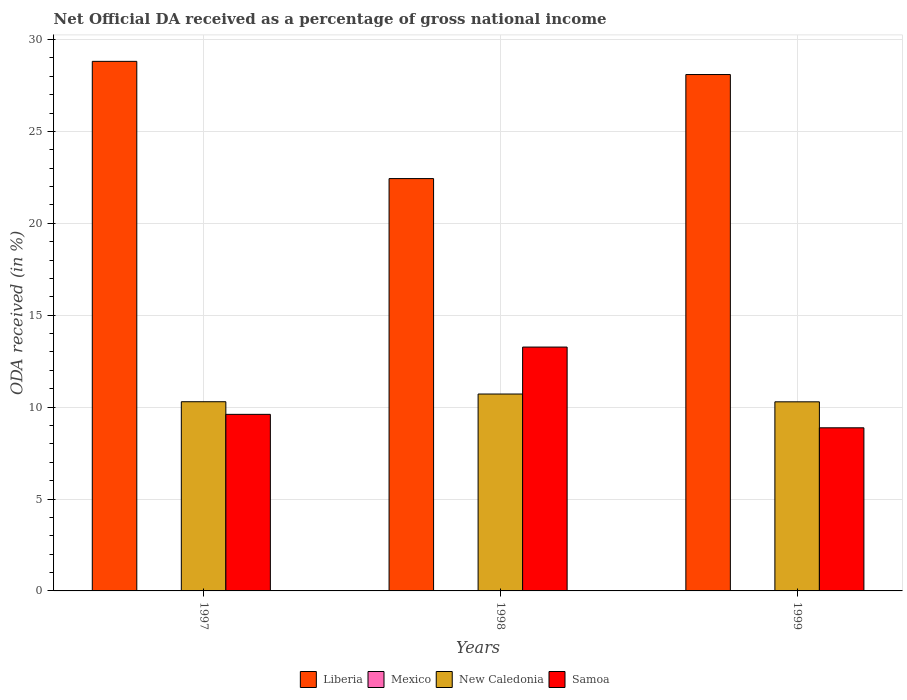How many different coloured bars are there?
Offer a very short reply. 4. Are the number of bars per tick equal to the number of legend labels?
Your answer should be very brief. Yes. How many bars are there on the 3rd tick from the left?
Ensure brevity in your answer.  4. How many bars are there on the 2nd tick from the right?
Offer a very short reply. 4. In how many cases, is the number of bars for a given year not equal to the number of legend labels?
Your response must be concise. 0. What is the net official DA received in Liberia in 1998?
Offer a terse response. 22.43. Across all years, what is the maximum net official DA received in New Caledonia?
Provide a short and direct response. 10.71. Across all years, what is the minimum net official DA received in Mexico?
Offer a terse response. 0. In which year was the net official DA received in Mexico minimum?
Give a very brief answer. 1998. What is the total net official DA received in Mexico in the graph?
Ensure brevity in your answer.  0.03. What is the difference between the net official DA received in New Caledonia in 1997 and that in 1999?
Your answer should be compact. 0.01. What is the difference between the net official DA received in New Caledonia in 1998 and the net official DA received in Liberia in 1999?
Your answer should be very brief. -17.38. What is the average net official DA received in Samoa per year?
Ensure brevity in your answer.  10.58. In the year 1998, what is the difference between the net official DA received in New Caledonia and net official DA received in Samoa?
Your answer should be compact. -2.55. In how many years, is the net official DA received in Mexico greater than 23 %?
Make the answer very short. 0. What is the ratio of the net official DA received in Samoa in 1997 to that in 1998?
Offer a very short reply. 0.72. What is the difference between the highest and the second highest net official DA received in New Caledonia?
Your answer should be compact. 0.42. What is the difference between the highest and the lowest net official DA received in New Caledonia?
Provide a succinct answer. 0.42. In how many years, is the net official DA received in Liberia greater than the average net official DA received in Liberia taken over all years?
Ensure brevity in your answer.  2. Is the sum of the net official DA received in Mexico in 1997 and 1999 greater than the maximum net official DA received in Samoa across all years?
Give a very brief answer. No. What does the 4th bar from the left in 1999 represents?
Offer a very short reply. Samoa. What does the 4th bar from the right in 1997 represents?
Keep it short and to the point. Liberia. Is it the case that in every year, the sum of the net official DA received in Mexico and net official DA received in New Caledonia is greater than the net official DA received in Samoa?
Offer a very short reply. No. How many bars are there?
Your answer should be compact. 12. Are all the bars in the graph horizontal?
Ensure brevity in your answer.  No. How many years are there in the graph?
Your response must be concise. 3. Are the values on the major ticks of Y-axis written in scientific E-notation?
Offer a terse response. No. Where does the legend appear in the graph?
Provide a succinct answer. Bottom center. How are the legend labels stacked?
Offer a terse response. Horizontal. What is the title of the graph?
Your response must be concise. Net Official DA received as a percentage of gross national income. Does "Kosovo" appear as one of the legend labels in the graph?
Provide a succinct answer. No. What is the label or title of the X-axis?
Give a very brief answer. Years. What is the label or title of the Y-axis?
Provide a succinct answer. ODA received (in %). What is the ODA received (in %) of Liberia in 1997?
Offer a terse response. 28.81. What is the ODA received (in %) in Mexico in 1997?
Ensure brevity in your answer.  0.02. What is the ODA received (in %) of New Caledonia in 1997?
Ensure brevity in your answer.  10.29. What is the ODA received (in %) in Samoa in 1997?
Ensure brevity in your answer.  9.61. What is the ODA received (in %) of Liberia in 1998?
Your answer should be compact. 22.43. What is the ODA received (in %) in Mexico in 1998?
Ensure brevity in your answer.  0. What is the ODA received (in %) of New Caledonia in 1998?
Keep it short and to the point. 10.71. What is the ODA received (in %) of Samoa in 1998?
Offer a terse response. 13.27. What is the ODA received (in %) of Liberia in 1999?
Your answer should be very brief. 28.1. What is the ODA received (in %) in Mexico in 1999?
Provide a succinct answer. 0.01. What is the ODA received (in %) of New Caledonia in 1999?
Your answer should be very brief. 10.29. What is the ODA received (in %) of Samoa in 1999?
Your answer should be very brief. 8.87. Across all years, what is the maximum ODA received (in %) of Liberia?
Keep it short and to the point. 28.81. Across all years, what is the maximum ODA received (in %) of Mexico?
Your answer should be very brief. 0.02. Across all years, what is the maximum ODA received (in %) in New Caledonia?
Your answer should be very brief. 10.71. Across all years, what is the maximum ODA received (in %) in Samoa?
Provide a succinct answer. 13.27. Across all years, what is the minimum ODA received (in %) of Liberia?
Offer a very short reply. 22.43. Across all years, what is the minimum ODA received (in %) of Mexico?
Provide a succinct answer. 0. Across all years, what is the minimum ODA received (in %) in New Caledonia?
Provide a short and direct response. 10.29. Across all years, what is the minimum ODA received (in %) of Samoa?
Your answer should be compact. 8.87. What is the total ODA received (in %) in Liberia in the graph?
Make the answer very short. 79.34. What is the total ODA received (in %) of Mexico in the graph?
Make the answer very short. 0.03. What is the total ODA received (in %) of New Caledonia in the graph?
Offer a terse response. 31.29. What is the total ODA received (in %) of Samoa in the graph?
Your answer should be very brief. 31.75. What is the difference between the ODA received (in %) of Liberia in 1997 and that in 1998?
Make the answer very short. 6.38. What is the difference between the ODA received (in %) of Mexico in 1997 and that in 1998?
Offer a terse response. 0.02. What is the difference between the ODA received (in %) of New Caledonia in 1997 and that in 1998?
Offer a terse response. -0.42. What is the difference between the ODA received (in %) of Samoa in 1997 and that in 1998?
Provide a short and direct response. -3.66. What is the difference between the ODA received (in %) in Liberia in 1997 and that in 1999?
Offer a terse response. 0.72. What is the difference between the ODA received (in %) in Mexico in 1997 and that in 1999?
Make the answer very short. 0.01. What is the difference between the ODA received (in %) in New Caledonia in 1997 and that in 1999?
Your answer should be very brief. 0.01. What is the difference between the ODA received (in %) in Samoa in 1997 and that in 1999?
Provide a short and direct response. 0.73. What is the difference between the ODA received (in %) of Liberia in 1998 and that in 1999?
Offer a very short reply. -5.66. What is the difference between the ODA received (in %) in Mexico in 1998 and that in 1999?
Your response must be concise. -0. What is the difference between the ODA received (in %) in New Caledonia in 1998 and that in 1999?
Your answer should be compact. 0.42. What is the difference between the ODA received (in %) in Samoa in 1998 and that in 1999?
Your response must be concise. 4.39. What is the difference between the ODA received (in %) in Liberia in 1997 and the ODA received (in %) in Mexico in 1998?
Your answer should be compact. 28.81. What is the difference between the ODA received (in %) of Liberia in 1997 and the ODA received (in %) of New Caledonia in 1998?
Ensure brevity in your answer.  18.1. What is the difference between the ODA received (in %) of Liberia in 1997 and the ODA received (in %) of Samoa in 1998?
Provide a short and direct response. 15.55. What is the difference between the ODA received (in %) of Mexico in 1997 and the ODA received (in %) of New Caledonia in 1998?
Provide a succinct answer. -10.69. What is the difference between the ODA received (in %) of Mexico in 1997 and the ODA received (in %) of Samoa in 1998?
Provide a short and direct response. -13.25. What is the difference between the ODA received (in %) of New Caledonia in 1997 and the ODA received (in %) of Samoa in 1998?
Give a very brief answer. -2.97. What is the difference between the ODA received (in %) of Liberia in 1997 and the ODA received (in %) of Mexico in 1999?
Offer a terse response. 28.81. What is the difference between the ODA received (in %) of Liberia in 1997 and the ODA received (in %) of New Caledonia in 1999?
Give a very brief answer. 18.52. What is the difference between the ODA received (in %) in Liberia in 1997 and the ODA received (in %) in Samoa in 1999?
Offer a very short reply. 19.94. What is the difference between the ODA received (in %) of Mexico in 1997 and the ODA received (in %) of New Caledonia in 1999?
Your answer should be very brief. -10.27. What is the difference between the ODA received (in %) of Mexico in 1997 and the ODA received (in %) of Samoa in 1999?
Your answer should be compact. -8.85. What is the difference between the ODA received (in %) of New Caledonia in 1997 and the ODA received (in %) of Samoa in 1999?
Offer a terse response. 1.42. What is the difference between the ODA received (in %) of Liberia in 1998 and the ODA received (in %) of Mexico in 1999?
Make the answer very short. 22.43. What is the difference between the ODA received (in %) of Liberia in 1998 and the ODA received (in %) of New Caledonia in 1999?
Your answer should be very brief. 12.15. What is the difference between the ODA received (in %) in Liberia in 1998 and the ODA received (in %) in Samoa in 1999?
Provide a succinct answer. 13.56. What is the difference between the ODA received (in %) of Mexico in 1998 and the ODA received (in %) of New Caledonia in 1999?
Give a very brief answer. -10.28. What is the difference between the ODA received (in %) in Mexico in 1998 and the ODA received (in %) in Samoa in 1999?
Give a very brief answer. -8.87. What is the difference between the ODA received (in %) in New Caledonia in 1998 and the ODA received (in %) in Samoa in 1999?
Ensure brevity in your answer.  1.84. What is the average ODA received (in %) in Liberia per year?
Ensure brevity in your answer.  26.45. What is the average ODA received (in %) in Mexico per year?
Your response must be concise. 0.01. What is the average ODA received (in %) of New Caledonia per year?
Your response must be concise. 10.43. What is the average ODA received (in %) in Samoa per year?
Offer a terse response. 10.58. In the year 1997, what is the difference between the ODA received (in %) of Liberia and ODA received (in %) of Mexico?
Offer a terse response. 28.79. In the year 1997, what is the difference between the ODA received (in %) in Liberia and ODA received (in %) in New Caledonia?
Make the answer very short. 18.52. In the year 1997, what is the difference between the ODA received (in %) of Liberia and ODA received (in %) of Samoa?
Provide a succinct answer. 19.21. In the year 1997, what is the difference between the ODA received (in %) in Mexico and ODA received (in %) in New Caledonia?
Offer a terse response. -10.27. In the year 1997, what is the difference between the ODA received (in %) in Mexico and ODA received (in %) in Samoa?
Provide a short and direct response. -9.59. In the year 1997, what is the difference between the ODA received (in %) in New Caledonia and ODA received (in %) in Samoa?
Provide a short and direct response. 0.69. In the year 1998, what is the difference between the ODA received (in %) in Liberia and ODA received (in %) in Mexico?
Your answer should be very brief. 22.43. In the year 1998, what is the difference between the ODA received (in %) of Liberia and ODA received (in %) of New Caledonia?
Make the answer very short. 11.72. In the year 1998, what is the difference between the ODA received (in %) in Liberia and ODA received (in %) in Samoa?
Your answer should be very brief. 9.17. In the year 1998, what is the difference between the ODA received (in %) of Mexico and ODA received (in %) of New Caledonia?
Make the answer very short. -10.71. In the year 1998, what is the difference between the ODA received (in %) in Mexico and ODA received (in %) in Samoa?
Offer a very short reply. -13.26. In the year 1998, what is the difference between the ODA received (in %) in New Caledonia and ODA received (in %) in Samoa?
Provide a succinct answer. -2.55. In the year 1999, what is the difference between the ODA received (in %) in Liberia and ODA received (in %) in Mexico?
Offer a very short reply. 28.09. In the year 1999, what is the difference between the ODA received (in %) in Liberia and ODA received (in %) in New Caledonia?
Your response must be concise. 17.81. In the year 1999, what is the difference between the ODA received (in %) in Liberia and ODA received (in %) in Samoa?
Ensure brevity in your answer.  19.22. In the year 1999, what is the difference between the ODA received (in %) in Mexico and ODA received (in %) in New Caledonia?
Offer a very short reply. -10.28. In the year 1999, what is the difference between the ODA received (in %) in Mexico and ODA received (in %) in Samoa?
Ensure brevity in your answer.  -8.87. In the year 1999, what is the difference between the ODA received (in %) of New Caledonia and ODA received (in %) of Samoa?
Your answer should be compact. 1.41. What is the ratio of the ODA received (in %) of Liberia in 1997 to that in 1998?
Offer a terse response. 1.28. What is the ratio of the ODA received (in %) in Mexico in 1997 to that in 1998?
Keep it short and to the point. 5.45. What is the ratio of the ODA received (in %) of New Caledonia in 1997 to that in 1998?
Give a very brief answer. 0.96. What is the ratio of the ODA received (in %) of Samoa in 1997 to that in 1998?
Ensure brevity in your answer.  0.72. What is the ratio of the ODA received (in %) of Liberia in 1997 to that in 1999?
Provide a succinct answer. 1.03. What is the ratio of the ODA received (in %) in Mexico in 1997 to that in 1999?
Keep it short and to the point. 3.36. What is the ratio of the ODA received (in %) in New Caledonia in 1997 to that in 1999?
Offer a very short reply. 1. What is the ratio of the ODA received (in %) in Samoa in 1997 to that in 1999?
Ensure brevity in your answer.  1.08. What is the ratio of the ODA received (in %) of Liberia in 1998 to that in 1999?
Your response must be concise. 0.8. What is the ratio of the ODA received (in %) of Mexico in 1998 to that in 1999?
Offer a terse response. 0.62. What is the ratio of the ODA received (in %) of New Caledonia in 1998 to that in 1999?
Your answer should be compact. 1.04. What is the ratio of the ODA received (in %) in Samoa in 1998 to that in 1999?
Offer a terse response. 1.49. What is the difference between the highest and the second highest ODA received (in %) in Liberia?
Your answer should be very brief. 0.72. What is the difference between the highest and the second highest ODA received (in %) of Mexico?
Give a very brief answer. 0.01. What is the difference between the highest and the second highest ODA received (in %) of New Caledonia?
Offer a terse response. 0.42. What is the difference between the highest and the second highest ODA received (in %) of Samoa?
Your answer should be very brief. 3.66. What is the difference between the highest and the lowest ODA received (in %) in Liberia?
Your answer should be compact. 6.38. What is the difference between the highest and the lowest ODA received (in %) of Mexico?
Offer a terse response. 0.02. What is the difference between the highest and the lowest ODA received (in %) in New Caledonia?
Your answer should be compact. 0.42. What is the difference between the highest and the lowest ODA received (in %) in Samoa?
Your answer should be very brief. 4.39. 